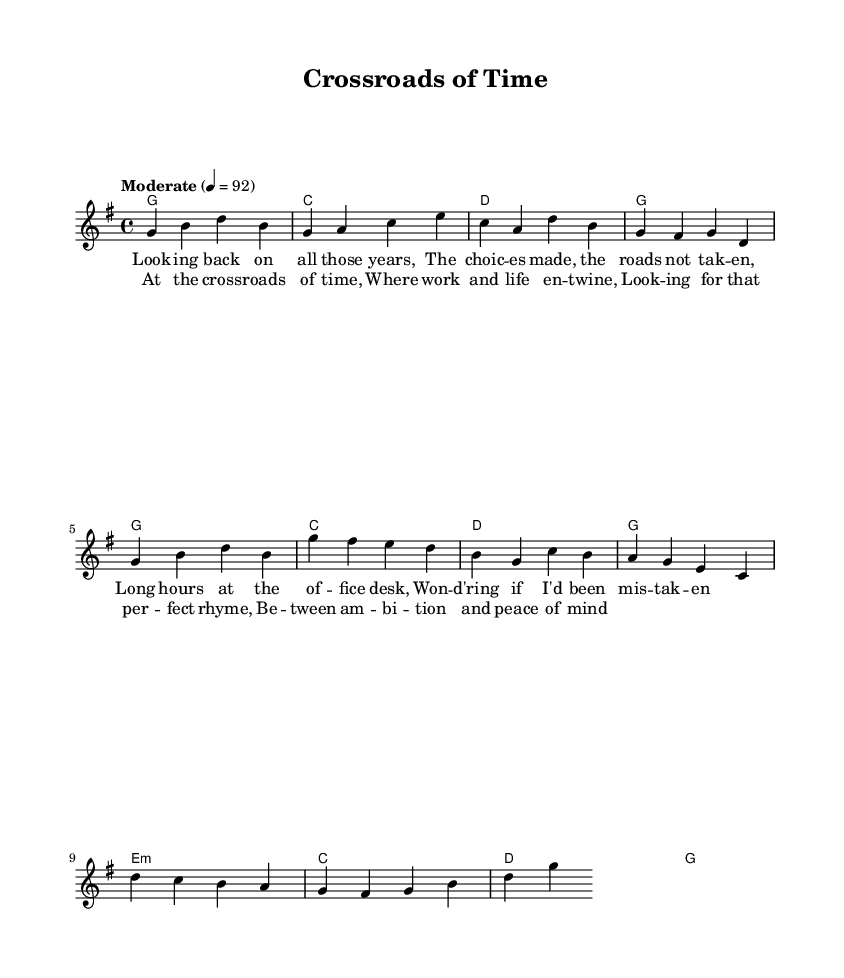What is the key signature of this music? The key signature is G major, which has one sharp (F#). This can be identified at the beginning of the staff where the key signature is indicated.
Answer: G major What is the time signature of this music? The time signature is 4/4, which means there are four beats in each measure and a quarter note gets one beat. This is typically indicated at the beginning of the staff after the clef sign.
Answer: 4/4 What is the tempo marking of this music? The tempo marking is "Moderate" with a metronome marking of 92 beats per minute. This indicates a moderate pace for the performance and is typically found at the beginning of the score.
Answer: Moderate 4 = 92 How many measures are in the chorus section? The chorus consists of four measures, as indicated by the musical notation where each measure is separated by vertical lines and corresponds to the lyrics provided.
Answer: 4 What are the first four lyrics of the verse section? The first four lyrics of the verse are "Looking back on all those years," as shown directly below the melody in the lyrics section of the sheet music.
Answer: Looking back on all those years Which chord is played in the second measure of the verse? The chord played in the second measure of the verse is C major, noted at the beginning of the second measure in the harmonies section.
Answer: C What is the overall theme reflected in the lyrics? The overall theme reflects introspection on career choices and balancing work and personal life, as indicated in the lyrics which discuss looking back and searching for harmony.
Answer: Introspection on career choices 